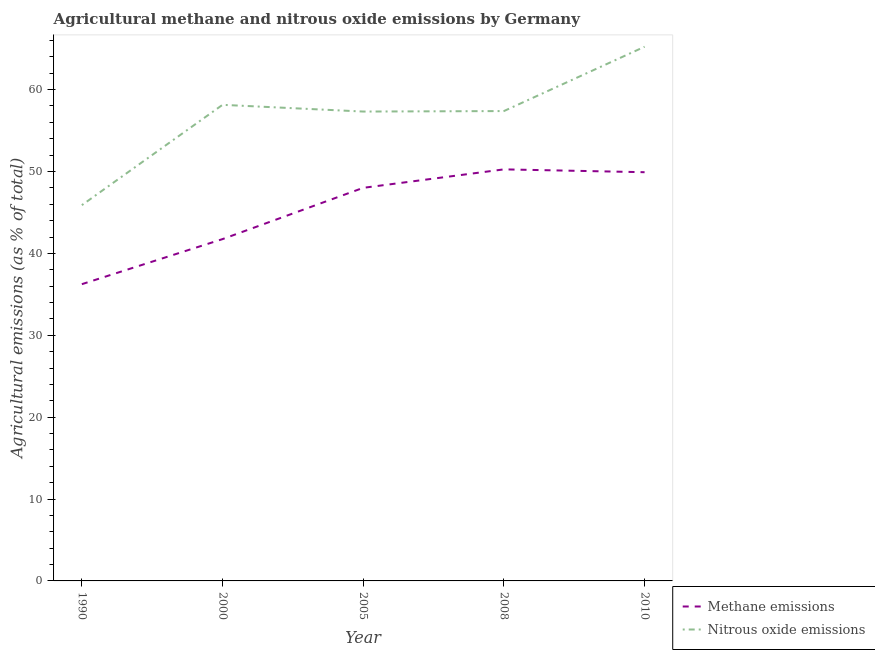What is the amount of methane emissions in 2005?
Provide a short and direct response. 48. Across all years, what is the maximum amount of nitrous oxide emissions?
Your answer should be compact. 65.23. Across all years, what is the minimum amount of methane emissions?
Offer a terse response. 36.24. What is the total amount of nitrous oxide emissions in the graph?
Your answer should be compact. 283.97. What is the difference between the amount of nitrous oxide emissions in 1990 and that in 2008?
Make the answer very short. -11.49. What is the difference between the amount of nitrous oxide emissions in 2005 and the amount of methane emissions in 2000?
Provide a short and direct response. 15.58. What is the average amount of nitrous oxide emissions per year?
Provide a short and direct response. 56.79. In the year 1990, what is the difference between the amount of methane emissions and amount of nitrous oxide emissions?
Ensure brevity in your answer.  -9.65. In how many years, is the amount of nitrous oxide emissions greater than 60 %?
Provide a succinct answer. 1. What is the ratio of the amount of nitrous oxide emissions in 2000 to that in 2008?
Offer a very short reply. 1.01. Is the amount of methane emissions in 2000 less than that in 2005?
Make the answer very short. Yes. What is the difference between the highest and the second highest amount of methane emissions?
Provide a succinct answer. 0.35. What is the difference between the highest and the lowest amount of methane emissions?
Your answer should be compact. 14.02. Is the amount of methane emissions strictly greater than the amount of nitrous oxide emissions over the years?
Keep it short and to the point. No. Is the amount of methane emissions strictly less than the amount of nitrous oxide emissions over the years?
Your answer should be compact. Yes. How many lines are there?
Your answer should be compact. 2. How many years are there in the graph?
Keep it short and to the point. 5. What is the difference between two consecutive major ticks on the Y-axis?
Keep it short and to the point. 10. How many legend labels are there?
Your answer should be compact. 2. How are the legend labels stacked?
Make the answer very short. Vertical. What is the title of the graph?
Your answer should be very brief. Agricultural methane and nitrous oxide emissions by Germany. What is the label or title of the X-axis?
Keep it short and to the point. Year. What is the label or title of the Y-axis?
Offer a very short reply. Agricultural emissions (as % of total). What is the Agricultural emissions (as % of total) in Methane emissions in 1990?
Ensure brevity in your answer.  36.24. What is the Agricultural emissions (as % of total) of Nitrous oxide emissions in 1990?
Your answer should be compact. 45.89. What is the Agricultural emissions (as % of total) in Methane emissions in 2000?
Ensure brevity in your answer.  41.74. What is the Agricultural emissions (as % of total) of Nitrous oxide emissions in 2000?
Your answer should be very brief. 58.14. What is the Agricultural emissions (as % of total) in Methane emissions in 2005?
Provide a short and direct response. 48. What is the Agricultural emissions (as % of total) of Nitrous oxide emissions in 2005?
Provide a short and direct response. 57.32. What is the Agricultural emissions (as % of total) of Methane emissions in 2008?
Provide a succinct answer. 50.26. What is the Agricultural emissions (as % of total) in Nitrous oxide emissions in 2008?
Keep it short and to the point. 57.38. What is the Agricultural emissions (as % of total) of Methane emissions in 2010?
Give a very brief answer. 49.91. What is the Agricultural emissions (as % of total) in Nitrous oxide emissions in 2010?
Give a very brief answer. 65.23. Across all years, what is the maximum Agricultural emissions (as % of total) of Methane emissions?
Ensure brevity in your answer.  50.26. Across all years, what is the maximum Agricultural emissions (as % of total) of Nitrous oxide emissions?
Your response must be concise. 65.23. Across all years, what is the minimum Agricultural emissions (as % of total) in Methane emissions?
Your response must be concise. 36.24. Across all years, what is the minimum Agricultural emissions (as % of total) of Nitrous oxide emissions?
Offer a terse response. 45.89. What is the total Agricultural emissions (as % of total) in Methane emissions in the graph?
Give a very brief answer. 226.16. What is the total Agricultural emissions (as % of total) in Nitrous oxide emissions in the graph?
Offer a very short reply. 283.97. What is the difference between the Agricultural emissions (as % of total) in Methane emissions in 1990 and that in 2000?
Provide a short and direct response. -5.5. What is the difference between the Agricultural emissions (as % of total) of Nitrous oxide emissions in 1990 and that in 2000?
Give a very brief answer. -12.25. What is the difference between the Agricultural emissions (as % of total) of Methane emissions in 1990 and that in 2005?
Make the answer very short. -11.77. What is the difference between the Agricultural emissions (as % of total) of Nitrous oxide emissions in 1990 and that in 2005?
Offer a terse response. -11.43. What is the difference between the Agricultural emissions (as % of total) of Methane emissions in 1990 and that in 2008?
Your response must be concise. -14.02. What is the difference between the Agricultural emissions (as % of total) of Nitrous oxide emissions in 1990 and that in 2008?
Offer a terse response. -11.49. What is the difference between the Agricultural emissions (as % of total) of Methane emissions in 1990 and that in 2010?
Ensure brevity in your answer.  -13.67. What is the difference between the Agricultural emissions (as % of total) in Nitrous oxide emissions in 1990 and that in 2010?
Ensure brevity in your answer.  -19.34. What is the difference between the Agricultural emissions (as % of total) of Methane emissions in 2000 and that in 2005?
Ensure brevity in your answer.  -6.26. What is the difference between the Agricultural emissions (as % of total) in Nitrous oxide emissions in 2000 and that in 2005?
Your response must be concise. 0.82. What is the difference between the Agricultural emissions (as % of total) in Methane emissions in 2000 and that in 2008?
Offer a very short reply. -8.52. What is the difference between the Agricultural emissions (as % of total) in Nitrous oxide emissions in 2000 and that in 2008?
Provide a short and direct response. 0.76. What is the difference between the Agricultural emissions (as % of total) in Methane emissions in 2000 and that in 2010?
Make the answer very short. -8.17. What is the difference between the Agricultural emissions (as % of total) of Nitrous oxide emissions in 2000 and that in 2010?
Your response must be concise. -7.09. What is the difference between the Agricultural emissions (as % of total) in Methane emissions in 2005 and that in 2008?
Offer a terse response. -2.26. What is the difference between the Agricultural emissions (as % of total) of Nitrous oxide emissions in 2005 and that in 2008?
Give a very brief answer. -0.06. What is the difference between the Agricultural emissions (as % of total) of Methane emissions in 2005 and that in 2010?
Keep it short and to the point. -1.91. What is the difference between the Agricultural emissions (as % of total) in Nitrous oxide emissions in 2005 and that in 2010?
Your answer should be compact. -7.91. What is the difference between the Agricultural emissions (as % of total) of Methane emissions in 2008 and that in 2010?
Offer a terse response. 0.35. What is the difference between the Agricultural emissions (as % of total) of Nitrous oxide emissions in 2008 and that in 2010?
Offer a terse response. -7.86. What is the difference between the Agricultural emissions (as % of total) in Methane emissions in 1990 and the Agricultural emissions (as % of total) in Nitrous oxide emissions in 2000?
Offer a terse response. -21.9. What is the difference between the Agricultural emissions (as % of total) in Methane emissions in 1990 and the Agricultural emissions (as % of total) in Nitrous oxide emissions in 2005?
Offer a very short reply. -21.08. What is the difference between the Agricultural emissions (as % of total) of Methane emissions in 1990 and the Agricultural emissions (as % of total) of Nitrous oxide emissions in 2008?
Keep it short and to the point. -21.14. What is the difference between the Agricultural emissions (as % of total) in Methane emissions in 1990 and the Agricultural emissions (as % of total) in Nitrous oxide emissions in 2010?
Offer a terse response. -29. What is the difference between the Agricultural emissions (as % of total) in Methane emissions in 2000 and the Agricultural emissions (as % of total) in Nitrous oxide emissions in 2005?
Offer a terse response. -15.58. What is the difference between the Agricultural emissions (as % of total) in Methane emissions in 2000 and the Agricultural emissions (as % of total) in Nitrous oxide emissions in 2008?
Provide a short and direct response. -15.64. What is the difference between the Agricultural emissions (as % of total) in Methane emissions in 2000 and the Agricultural emissions (as % of total) in Nitrous oxide emissions in 2010?
Your answer should be compact. -23.49. What is the difference between the Agricultural emissions (as % of total) of Methane emissions in 2005 and the Agricultural emissions (as % of total) of Nitrous oxide emissions in 2008?
Ensure brevity in your answer.  -9.37. What is the difference between the Agricultural emissions (as % of total) in Methane emissions in 2005 and the Agricultural emissions (as % of total) in Nitrous oxide emissions in 2010?
Your response must be concise. -17.23. What is the difference between the Agricultural emissions (as % of total) of Methane emissions in 2008 and the Agricultural emissions (as % of total) of Nitrous oxide emissions in 2010?
Provide a short and direct response. -14.97. What is the average Agricultural emissions (as % of total) of Methane emissions per year?
Make the answer very short. 45.23. What is the average Agricultural emissions (as % of total) in Nitrous oxide emissions per year?
Your answer should be compact. 56.79. In the year 1990, what is the difference between the Agricultural emissions (as % of total) in Methane emissions and Agricultural emissions (as % of total) in Nitrous oxide emissions?
Your response must be concise. -9.65. In the year 2000, what is the difference between the Agricultural emissions (as % of total) of Methane emissions and Agricultural emissions (as % of total) of Nitrous oxide emissions?
Offer a terse response. -16.4. In the year 2005, what is the difference between the Agricultural emissions (as % of total) of Methane emissions and Agricultural emissions (as % of total) of Nitrous oxide emissions?
Your answer should be compact. -9.32. In the year 2008, what is the difference between the Agricultural emissions (as % of total) of Methane emissions and Agricultural emissions (as % of total) of Nitrous oxide emissions?
Make the answer very short. -7.12. In the year 2010, what is the difference between the Agricultural emissions (as % of total) of Methane emissions and Agricultural emissions (as % of total) of Nitrous oxide emissions?
Offer a terse response. -15.32. What is the ratio of the Agricultural emissions (as % of total) of Methane emissions in 1990 to that in 2000?
Offer a terse response. 0.87. What is the ratio of the Agricultural emissions (as % of total) of Nitrous oxide emissions in 1990 to that in 2000?
Offer a terse response. 0.79. What is the ratio of the Agricultural emissions (as % of total) of Methane emissions in 1990 to that in 2005?
Your answer should be compact. 0.75. What is the ratio of the Agricultural emissions (as % of total) in Nitrous oxide emissions in 1990 to that in 2005?
Your response must be concise. 0.8. What is the ratio of the Agricultural emissions (as % of total) of Methane emissions in 1990 to that in 2008?
Give a very brief answer. 0.72. What is the ratio of the Agricultural emissions (as % of total) of Nitrous oxide emissions in 1990 to that in 2008?
Your response must be concise. 0.8. What is the ratio of the Agricultural emissions (as % of total) of Methane emissions in 1990 to that in 2010?
Your answer should be compact. 0.73. What is the ratio of the Agricultural emissions (as % of total) in Nitrous oxide emissions in 1990 to that in 2010?
Offer a terse response. 0.7. What is the ratio of the Agricultural emissions (as % of total) of Methane emissions in 2000 to that in 2005?
Ensure brevity in your answer.  0.87. What is the ratio of the Agricultural emissions (as % of total) of Nitrous oxide emissions in 2000 to that in 2005?
Provide a succinct answer. 1.01. What is the ratio of the Agricultural emissions (as % of total) in Methane emissions in 2000 to that in 2008?
Keep it short and to the point. 0.83. What is the ratio of the Agricultural emissions (as % of total) in Nitrous oxide emissions in 2000 to that in 2008?
Keep it short and to the point. 1.01. What is the ratio of the Agricultural emissions (as % of total) in Methane emissions in 2000 to that in 2010?
Offer a very short reply. 0.84. What is the ratio of the Agricultural emissions (as % of total) in Nitrous oxide emissions in 2000 to that in 2010?
Offer a terse response. 0.89. What is the ratio of the Agricultural emissions (as % of total) in Methane emissions in 2005 to that in 2008?
Keep it short and to the point. 0.96. What is the ratio of the Agricultural emissions (as % of total) of Methane emissions in 2005 to that in 2010?
Offer a terse response. 0.96. What is the ratio of the Agricultural emissions (as % of total) of Nitrous oxide emissions in 2005 to that in 2010?
Your answer should be compact. 0.88. What is the ratio of the Agricultural emissions (as % of total) in Nitrous oxide emissions in 2008 to that in 2010?
Provide a short and direct response. 0.88. What is the difference between the highest and the second highest Agricultural emissions (as % of total) of Methane emissions?
Offer a terse response. 0.35. What is the difference between the highest and the second highest Agricultural emissions (as % of total) of Nitrous oxide emissions?
Your answer should be compact. 7.09. What is the difference between the highest and the lowest Agricultural emissions (as % of total) of Methane emissions?
Keep it short and to the point. 14.02. What is the difference between the highest and the lowest Agricultural emissions (as % of total) in Nitrous oxide emissions?
Offer a terse response. 19.34. 